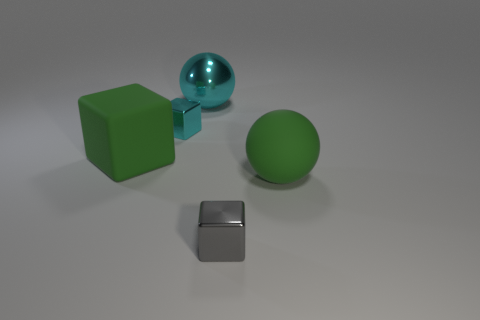Add 1 small brown cylinders. How many objects exist? 6 Subtract all shiny cubes. How many cubes are left? 1 Subtract all green balls. How many balls are left? 1 Subtract 0 brown cubes. How many objects are left? 5 Subtract all blocks. How many objects are left? 2 Subtract 1 balls. How many balls are left? 1 Subtract all brown balls. Subtract all gray cubes. How many balls are left? 2 Subtract all gray cylinders. How many purple spheres are left? 0 Subtract all large green rubber objects. Subtract all tiny gray metallic blocks. How many objects are left? 2 Add 5 small cubes. How many small cubes are left? 7 